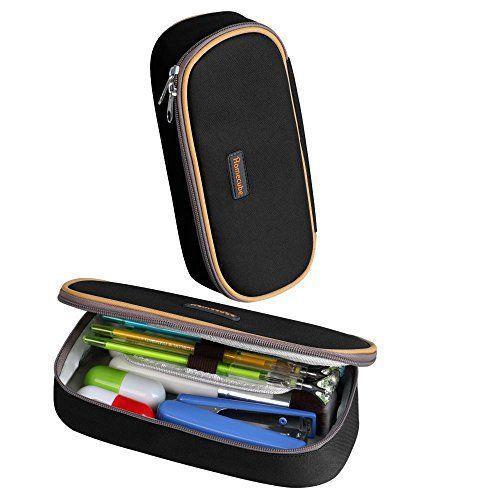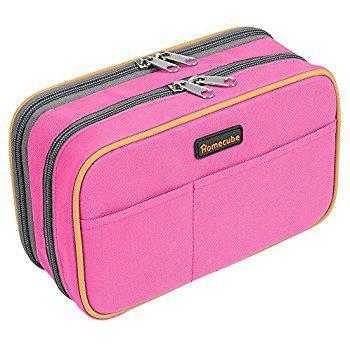The first image is the image on the left, the second image is the image on the right. Evaluate the accuracy of this statement regarding the images: "Both cases are open to reveal their contents.". Is it true? Answer yes or no. No. The first image is the image on the left, the second image is the image on the right. For the images shown, is this caption "Each image shows an open pencil case containing a row of writing implements in a pouch." true? Answer yes or no. No. 